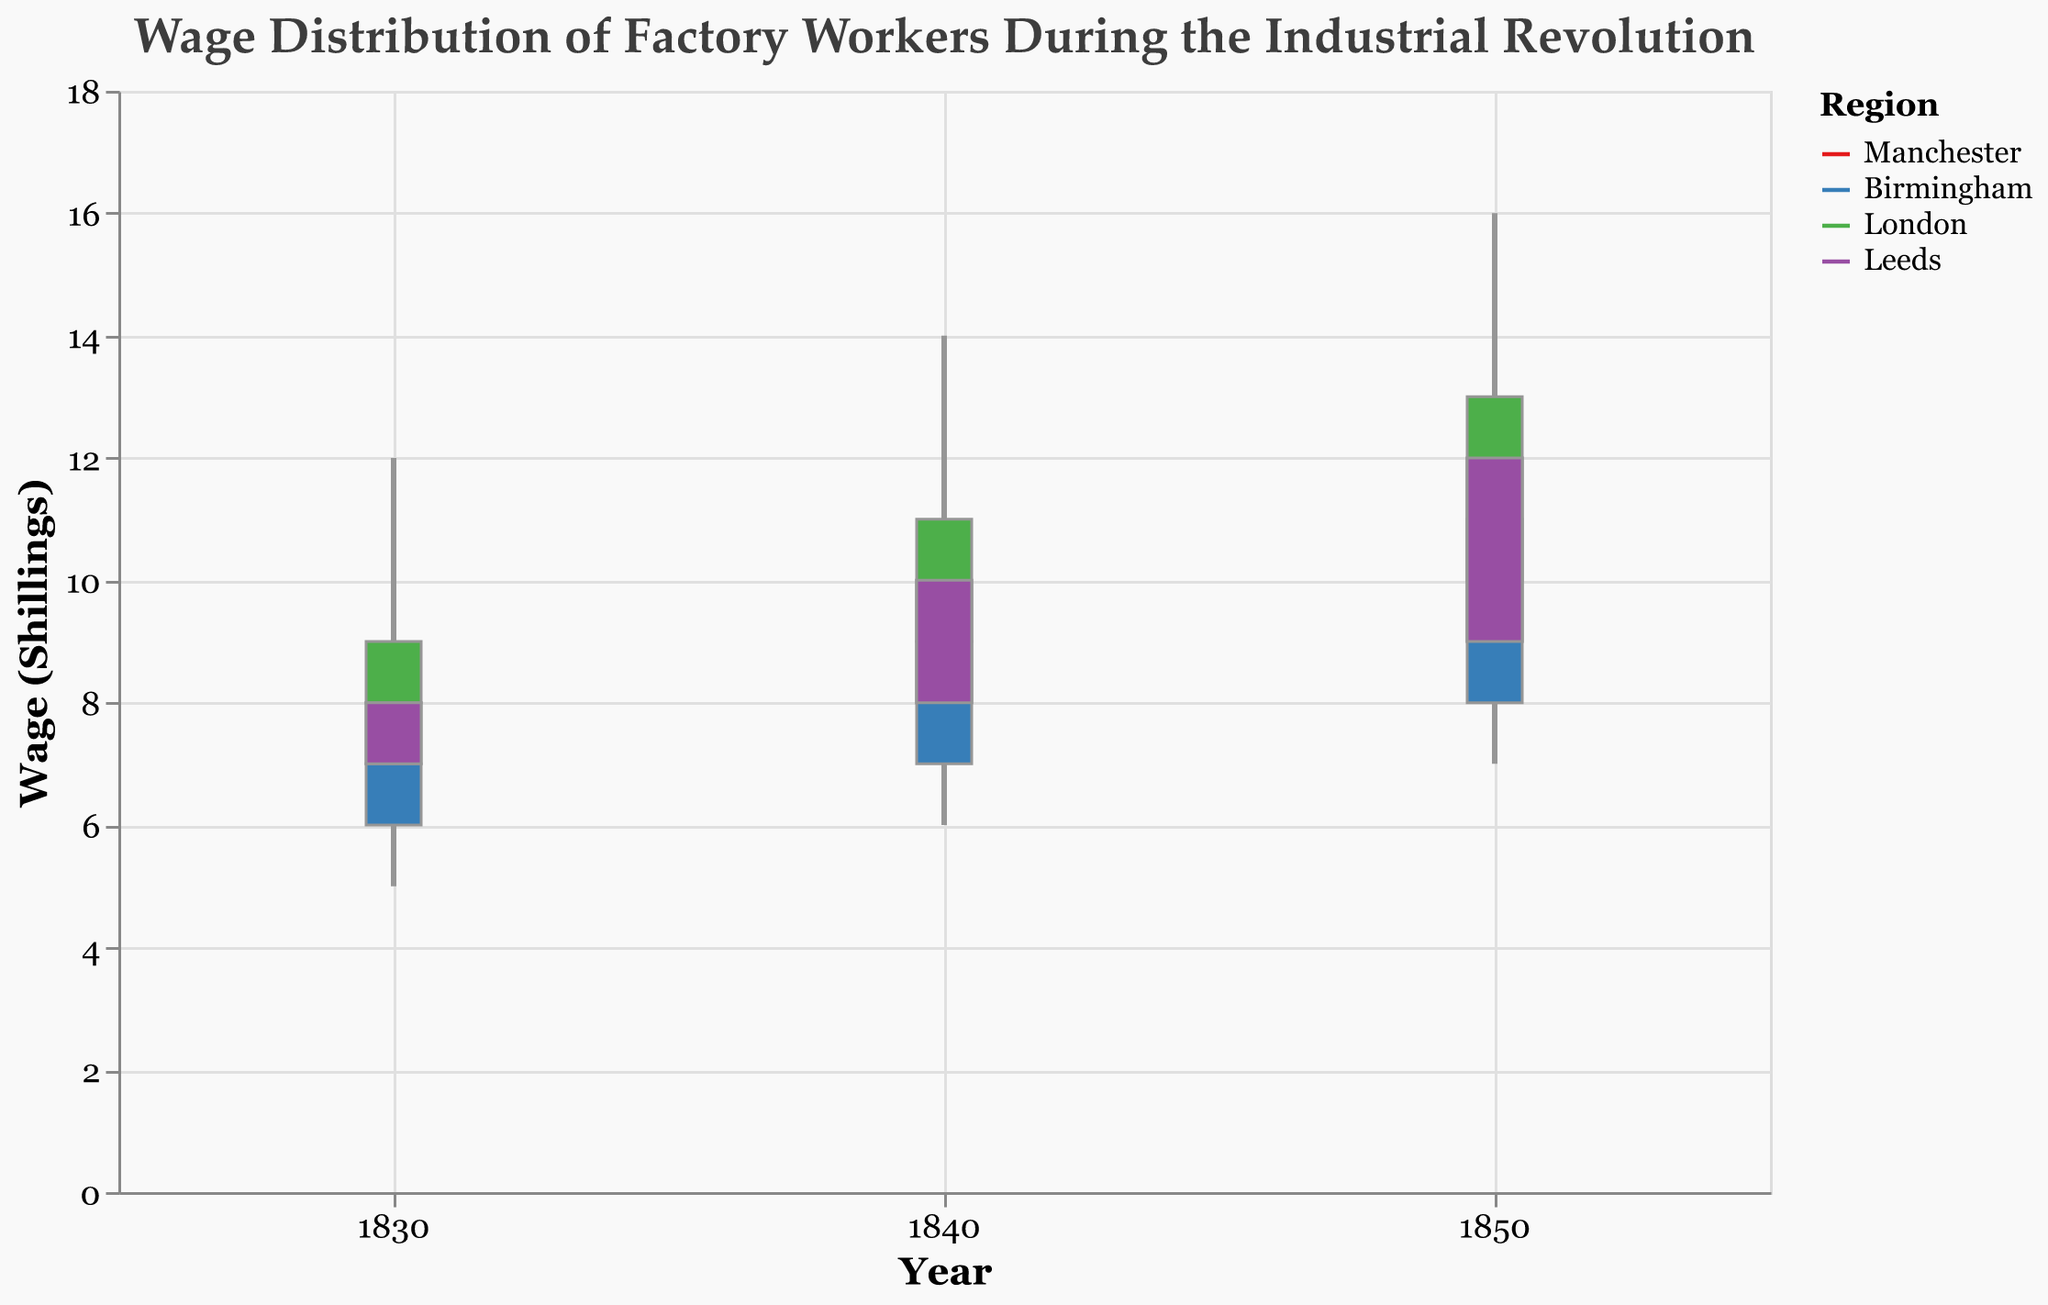What is the title of the plot? The title is the text that appears at the top of the figure. It's "Wage Distribution of Factory Workers During the Industrial Revolution."
Answer: Wage Distribution of Factory Workers During the Industrial Revolution Which region has the highest wage recorded in 1850? Look at the bars for 1850 and check the 'High' values for all regions. London has a 'High' value of 16 shillings, the highest compared to Manchester (15), Birmingham (13), and Leeds (14).
Answer: London What is the range of wages in Manchester in 1840? The wage range is the difference between the 'High' and 'Low' values for Manchester in 1840. The 'High' is 12 shillings and the 'Low' is 7 shillings, so the range is 12 - 7 = 5 shillings.
Answer: 5 shillings Which region showed the greatest increase in 'Close' wages from 1830 to 1850? Identify the 'Close' wages for 1830 (Manchester: 8, Birmingham: 7, London: 9, Leeds: 8) and for 1850 (Manchester: 12, Birmingham: 11, London: 13, Leeds: 12). Calculate the increases: Manchester (12-8=4), Birmingham (11-7=4), London (13-9=4), Leeds (12-8=4). All regions increased equally by 4 shillings.
Answer: All regions What is the average 'High' wage in Birmingham across the years provided? Summarize the 'High' wages for Birmingham across the three years given (8 in 1830, 11 in 1840, 13 in 1850). The total is 8 + 11 + 13 = 32. Divide by the number of years (3), so the average is 32/3 ≈ 10.67 shillings.
Answer: ≈ 10.67 shillings How does the wage disparity (High-Low difference) in Leeds in 1830 compare to 1850? Calculate the wage disparity for Leeds in 1830 (High 11, Low 6: 11 - 6 = 5) and in 1850 (High 14, Low 8: 14 - 8 = 6). The disparity increased by 1 shilling from 1830 to 1850.
Answer: Increased by 1 shilling In which year did London experience the highest increase in 'Close' wages compared to the previous decade? Calculate the 'Close' wage increase in London: from 1830 (9) to 1840 (11), an increase of 2 shillings, and from 1840 (11) to 1850 (13), an increase of 2 shillings. Both decades had the same increase.
Answer: Both decades Which region exhibited the least variability in wages in 1830? Identify the 'High' and 'Low' values for 1830 for each region: Manchester (High 10, Low 6), Birmingham (High 8, Low 5), London (High 12, Low 7), Leeds (High 11, Low 6). Calculate the range: Manchester (10-6=4), Birmingham (8-5=3), London (12-7=5), Leeds (11-6=5). Birmingham has the smallest range, showing least variability.
Answer: Birmingham 